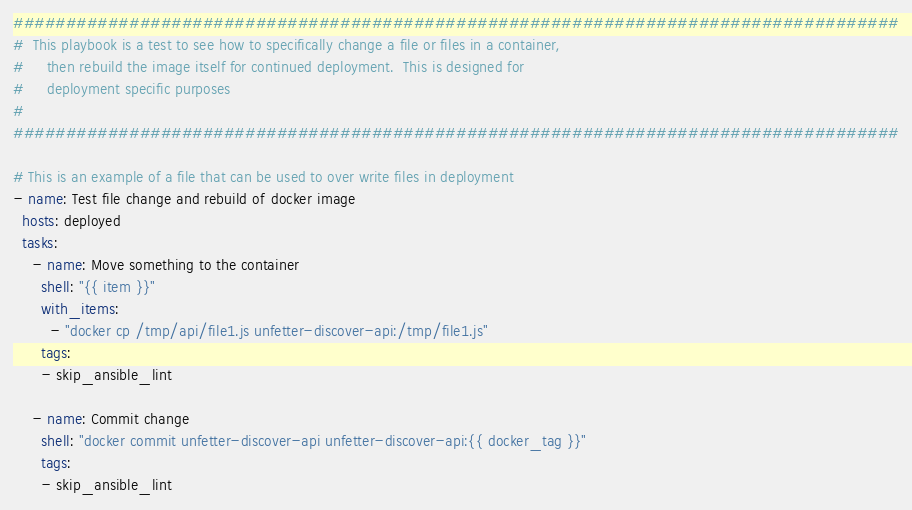<code> <loc_0><loc_0><loc_500><loc_500><_YAML_>####################################################################################
#  This playbook is a test to see how to specifically change a file or files in a container,
#     then rebuild the image itself for continued deployment.  This is designed for
#     deployment specific purposes
#
####################################################################################

# This is an example of a file that can be used to over write files in deployment
- name: Test file change and rebuild of docker image
  hosts: deployed
  tasks:
    - name: Move something to the container
      shell: "{{ item }}"
      with_items:
        - "docker cp /tmp/api/file1.js unfetter-discover-api:/tmp/file1.js"
      tags:
      - skip_ansible_lint

    - name: Commit change
      shell: "docker commit unfetter-discover-api unfetter-discover-api:{{ docker_tag }}"
      tags:
      - skip_ansible_lint
</code> 